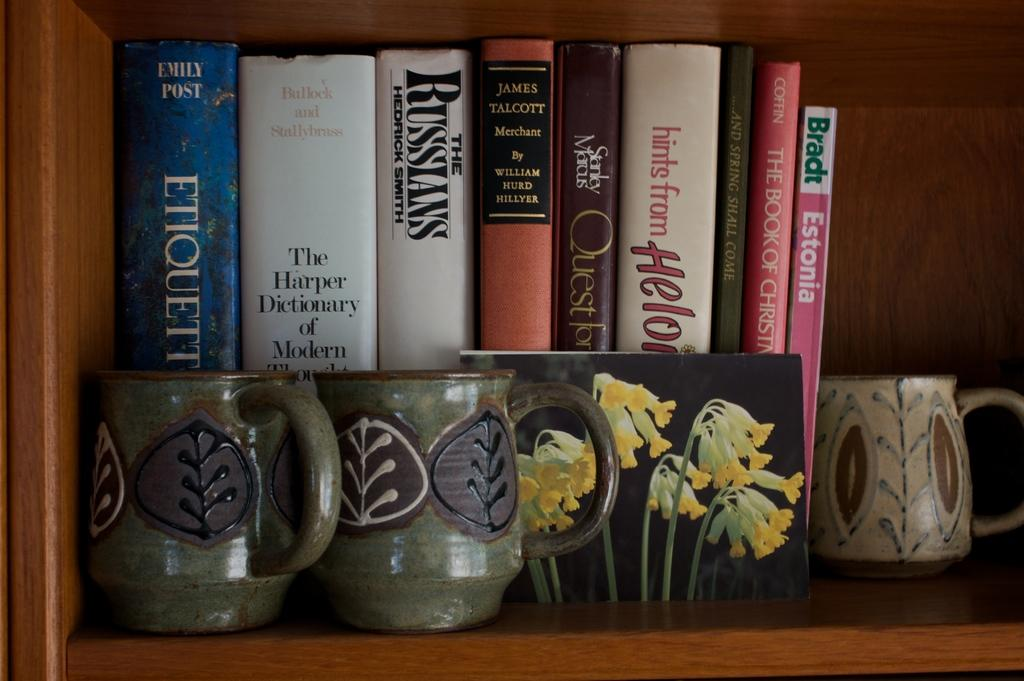<image>
Present a compact description of the photo's key features. The Russians is on the bookshelf with a few other books. 